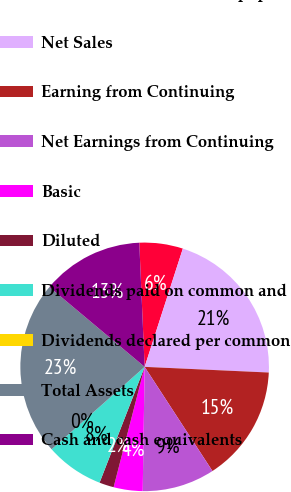<chart> <loc_0><loc_0><loc_500><loc_500><pie_chart><fcel>Amounts in Millions except per<fcel>Net Sales<fcel>Earning from Continuing<fcel>Net Earnings from Continuing<fcel>Basic<fcel>Diluted<fcel>Dividends paid on common and<fcel>Dividends declared per common<fcel>Total Assets<fcel>Cash and cash equivalents<nl><fcel>5.66%<fcel>20.75%<fcel>15.09%<fcel>9.43%<fcel>3.77%<fcel>1.89%<fcel>7.55%<fcel>0.0%<fcel>22.64%<fcel>13.21%<nl></chart> 